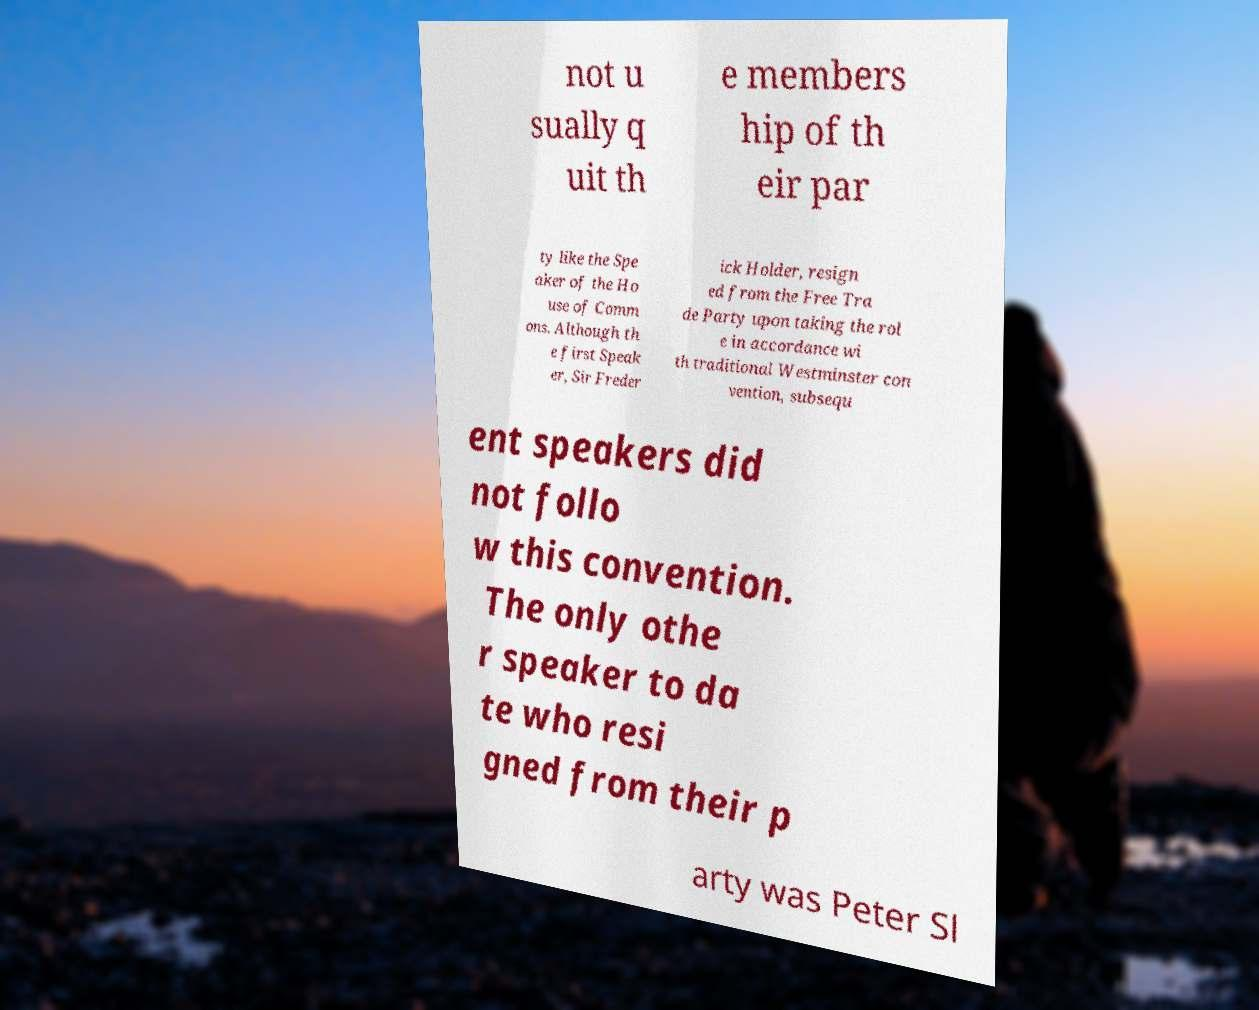Can you read and provide the text displayed in the image?This photo seems to have some interesting text. Can you extract and type it out for me? not u sually q uit th e members hip of th eir par ty like the Spe aker of the Ho use of Comm ons. Although th e first Speak er, Sir Freder ick Holder, resign ed from the Free Tra de Party upon taking the rol e in accordance wi th traditional Westminster con vention, subsequ ent speakers did not follo w this convention. The only othe r speaker to da te who resi gned from their p arty was Peter Sl 